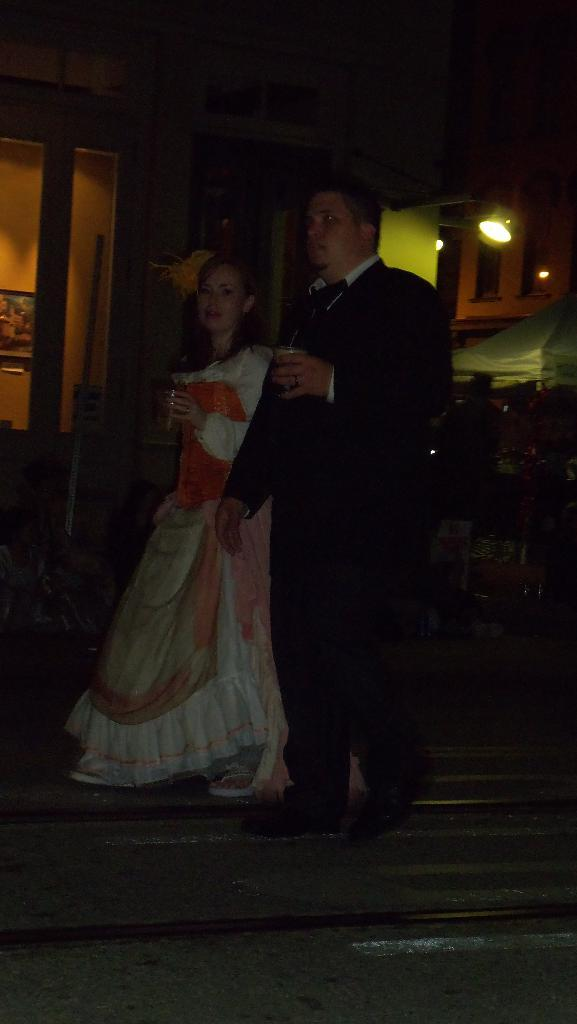At what time of day was the image taken? The image was taken during night. How many people are in the image? There are two persons in the image. What are the persons holding in their hands? The persons are holding glasses. What can be seen in the background of the image? There are lights, buildings, and poles visible in the background. Can you see the baby smiling in the image? There is no baby present in the image, so it is not possible to see a baby smiling. 